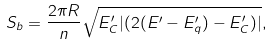<formula> <loc_0><loc_0><loc_500><loc_500>S _ { b } = \frac { 2 \pi R } { n } \sqrt { E ^ { \prime } _ { C } | ( 2 ( E ^ { \prime } - E ^ { \prime } _ { q } ) - E ^ { \prime } _ { C } ) | } ,</formula> 